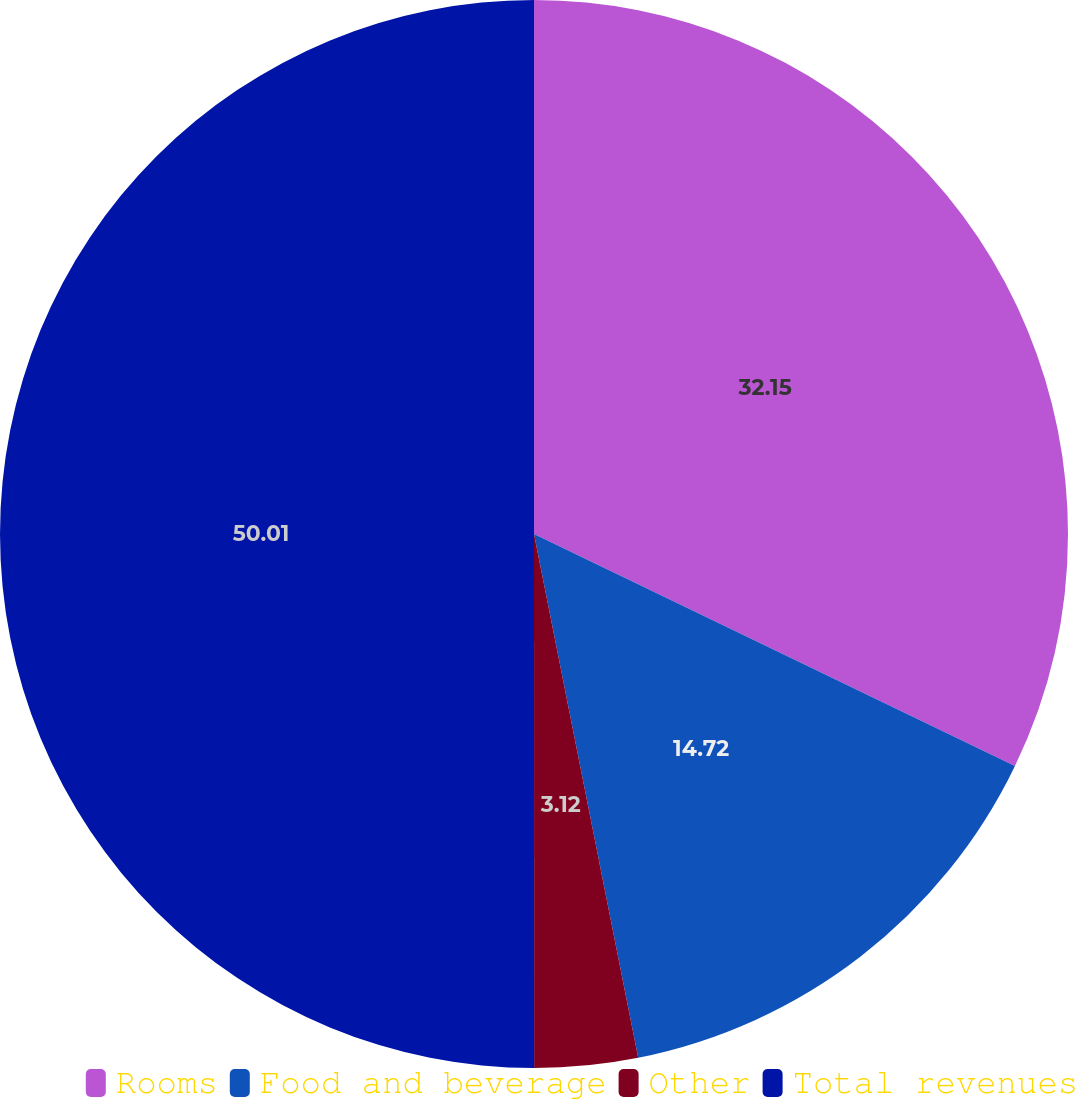Convert chart to OTSL. <chart><loc_0><loc_0><loc_500><loc_500><pie_chart><fcel>Rooms<fcel>Food and beverage<fcel>Other<fcel>Total revenues<nl><fcel>32.15%<fcel>14.72%<fcel>3.12%<fcel>50.0%<nl></chart> 